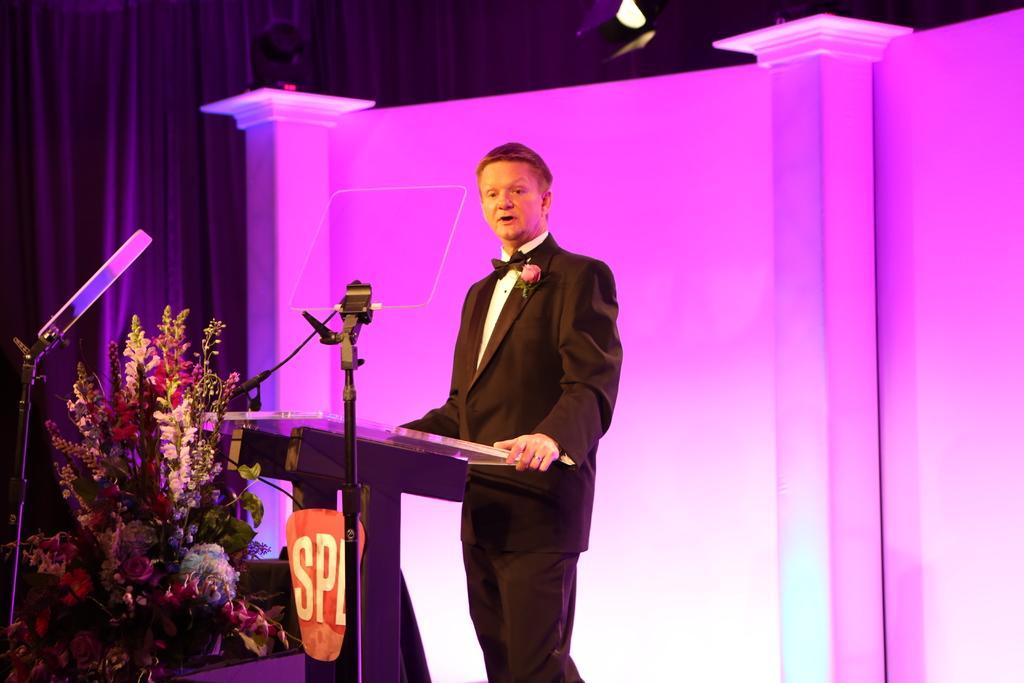How would you summarize this image in a sentence or two? In this picture I can observe a man standing in front of a podium in the middle of the picture. He is wearing a coat. On the left side I can observe a bouquet. In the background I can observe black color curtain. 